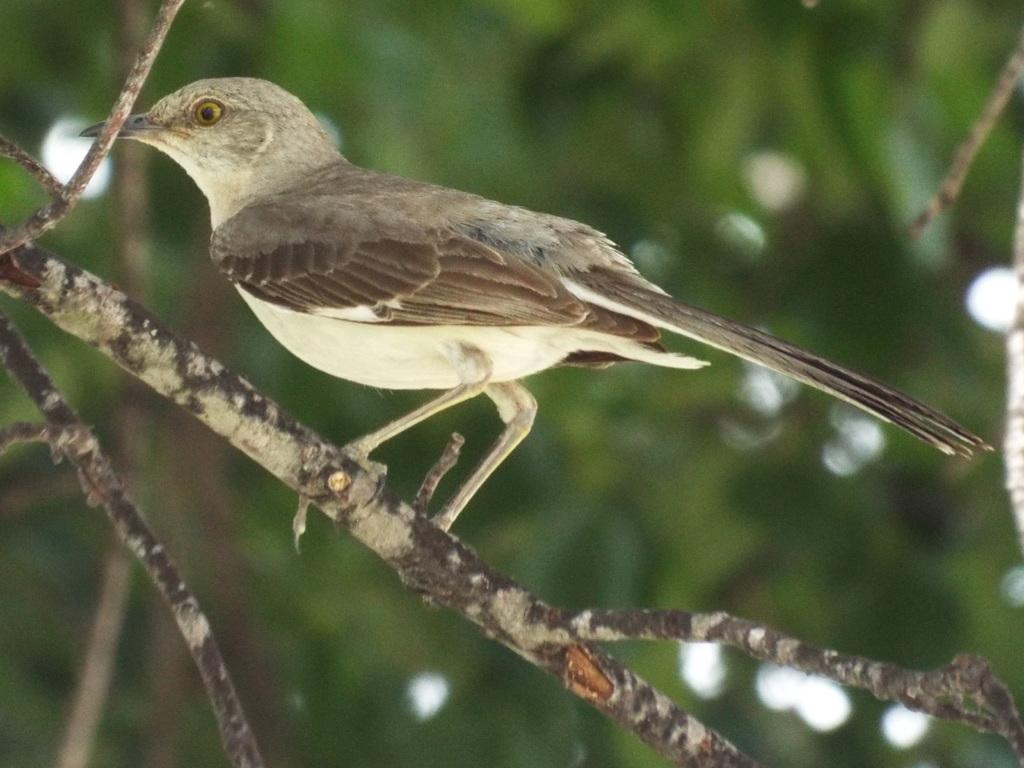What type of animal is in the image? There is a bird in the image. Where is the bird located? The bird is on a branch. Can you describe the background of the image? The background of the image is blurry. What type of books can be seen in the bird's nest in the image? There are no books present in the image, and the bird is not shown to have a nest. 